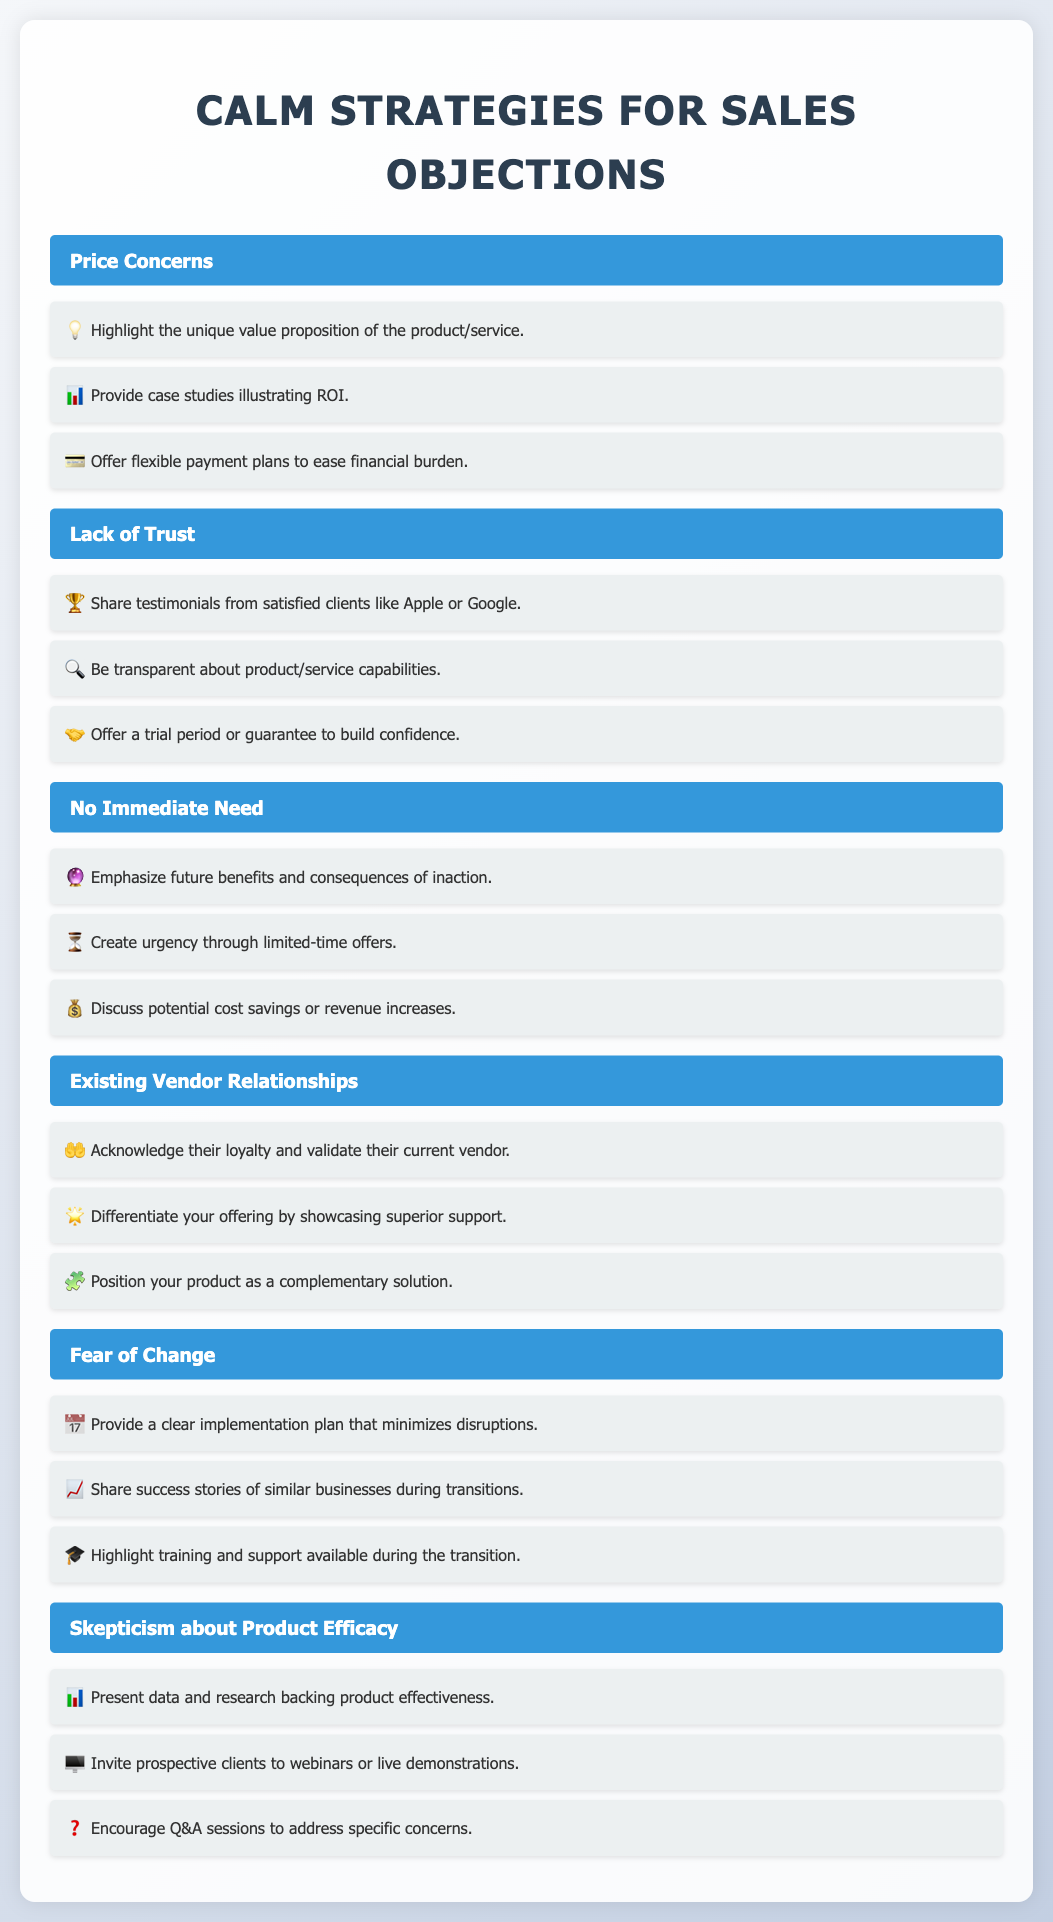What is the title of the document? The title is found in the `<title>` tag of the HTML structure, which is "Sales Objections Strategies."
Answer: Sales Objections Strategies How many objections are outlined in the document? The objections are listed as separate sections in the document, and counting them shows five distinct objections.
Answer: 5 What icon represents the strategy for price concerns? The icon used for the strategy under price concerns is highlighted next to each strategy listed. The first strategy has the lightbulb icon.
Answer: 💡 What is one strategy for addressing lack of trust? The strategies for lack of trust are provided under the corresponding section, such as sharing testimonials.
Answer: Share testimonials What is the strategy icon for creating urgency? The strategy icons are presented next to each strategy, and the urgency strategy uses the hourglass icon.
Answer: ⏳ What is a suggested approach for addressing fear of change? The potential strategies related to fear of change can be found in that section, which includes providing a clear implementation plan.
Answer: Provide a clear implementation plan Which objection is associated with the icon for skepticism about product efficacy? The skepticism section has specific strategies, and it is connected with a data-related icon.
Answer: 📊 What type of document is this? This document serves as a note structured to present objections and corresponding strategies in sales effectively.
Answer: Note What color is used for the headers of the objections? Each objection header has a specific color applied to it for emphasis in the visual presentation.
Answer: Blue 